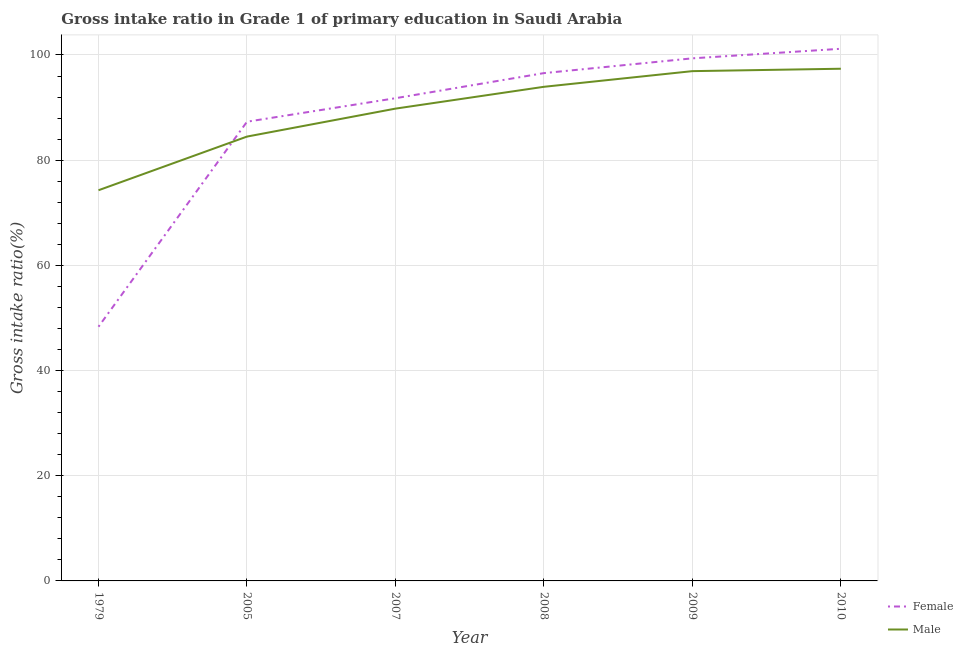Does the line corresponding to gross intake ratio(female) intersect with the line corresponding to gross intake ratio(male)?
Offer a terse response. Yes. What is the gross intake ratio(female) in 1979?
Make the answer very short. 48.33. Across all years, what is the maximum gross intake ratio(male)?
Your response must be concise. 97.39. Across all years, what is the minimum gross intake ratio(male)?
Make the answer very short. 74.28. In which year was the gross intake ratio(female) minimum?
Keep it short and to the point. 1979. What is the total gross intake ratio(male) in the graph?
Provide a short and direct response. 536.83. What is the difference between the gross intake ratio(male) in 1979 and that in 2010?
Offer a terse response. -23.1. What is the difference between the gross intake ratio(male) in 1979 and the gross intake ratio(female) in 2008?
Offer a very short reply. -22.27. What is the average gross intake ratio(male) per year?
Your response must be concise. 89.47. In the year 2010, what is the difference between the gross intake ratio(female) and gross intake ratio(male)?
Your response must be concise. 3.79. What is the ratio of the gross intake ratio(female) in 2005 to that in 2009?
Your answer should be compact. 0.88. Is the gross intake ratio(male) in 2005 less than that in 2007?
Your response must be concise. Yes. What is the difference between the highest and the second highest gross intake ratio(female)?
Offer a very short reply. 1.82. What is the difference between the highest and the lowest gross intake ratio(female)?
Ensure brevity in your answer.  52.85. In how many years, is the gross intake ratio(female) greater than the average gross intake ratio(female) taken over all years?
Offer a terse response. 4. Is the sum of the gross intake ratio(female) in 2005 and 2010 greater than the maximum gross intake ratio(male) across all years?
Your answer should be very brief. Yes. Does the gross intake ratio(female) monotonically increase over the years?
Provide a short and direct response. Yes. Is the gross intake ratio(male) strictly greater than the gross intake ratio(female) over the years?
Your answer should be compact. No. What is the difference between two consecutive major ticks on the Y-axis?
Offer a very short reply. 20. Are the values on the major ticks of Y-axis written in scientific E-notation?
Your answer should be compact. No. Does the graph contain any zero values?
Provide a succinct answer. No. Where does the legend appear in the graph?
Ensure brevity in your answer.  Bottom right. How many legend labels are there?
Your answer should be compact. 2. What is the title of the graph?
Keep it short and to the point. Gross intake ratio in Grade 1 of primary education in Saudi Arabia. What is the label or title of the Y-axis?
Your response must be concise. Gross intake ratio(%). What is the Gross intake ratio(%) of Female in 1979?
Offer a very short reply. 48.33. What is the Gross intake ratio(%) in Male in 1979?
Give a very brief answer. 74.28. What is the Gross intake ratio(%) in Female in 2005?
Provide a short and direct response. 87.31. What is the Gross intake ratio(%) of Male in 2005?
Provide a succinct answer. 84.49. What is the Gross intake ratio(%) of Female in 2007?
Keep it short and to the point. 91.78. What is the Gross intake ratio(%) of Male in 2007?
Your response must be concise. 89.8. What is the Gross intake ratio(%) in Female in 2008?
Provide a succinct answer. 96.55. What is the Gross intake ratio(%) in Male in 2008?
Offer a very short reply. 93.95. What is the Gross intake ratio(%) of Female in 2009?
Your response must be concise. 99.36. What is the Gross intake ratio(%) in Male in 2009?
Offer a very short reply. 96.93. What is the Gross intake ratio(%) in Female in 2010?
Your response must be concise. 101.18. What is the Gross intake ratio(%) in Male in 2010?
Ensure brevity in your answer.  97.39. Across all years, what is the maximum Gross intake ratio(%) of Female?
Your response must be concise. 101.18. Across all years, what is the maximum Gross intake ratio(%) of Male?
Your response must be concise. 97.39. Across all years, what is the minimum Gross intake ratio(%) in Female?
Your response must be concise. 48.33. Across all years, what is the minimum Gross intake ratio(%) of Male?
Give a very brief answer. 74.28. What is the total Gross intake ratio(%) of Female in the graph?
Ensure brevity in your answer.  524.52. What is the total Gross intake ratio(%) in Male in the graph?
Your answer should be compact. 536.83. What is the difference between the Gross intake ratio(%) in Female in 1979 and that in 2005?
Give a very brief answer. -38.98. What is the difference between the Gross intake ratio(%) in Male in 1979 and that in 2005?
Keep it short and to the point. -10.2. What is the difference between the Gross intake ratio(%) in Female in 1979 and that in 2007?
Make the answer very short. -43.45. What is the difference between the Gross intake ratio(%) of Male in 1979 and that in 2007?
Provide a short and direct response. -15.52. What is the difference between the Gross intake ratio(%) in Female in 1979 and that in 2008?
Keep it short and to the point. -48.22. What is the difference between the Gross intake ratio(%) of Male in 1979 and that in 2008?
Keep it short and to the point. -19.67. What is the difference between the Gross intake ratio(%) of Female in 1979 and that in 2009?
Your answer should be very brief. -51.03. What is the difference between the Gross intake ratio(%) in Male in 1979 and that in 2009?
Offer a very short reply. -22.65. What is the difference between the Gross intake ratio(%) of Female in 1979 and that in 2010?
Provide a short and direct response. -52.85. What is the difference between the Gross intake ratio(%) in Male in 1979 and that in 2010?
Your response must be concise. -23.1. What is the difference between the Gross intake ratio(%) of Female in 2005 and that in 2007?
Your answer should be compact. -4.47. What is the difference between the Gross intake ratio(%) of Male in 2005 and that in 2007?
Provide a succinct answer. -5.31. What is the difference between the Gross intake ratio(%) of Female in 2005 and that in 2008?
Your answer should be very brief. -9.24. What is the difference between the Gross intake ratio(%) in Male in 2005 and that in 2008?
Keep it short and to the point. -9.46. What is the difference between the Gross intake ratio(%) of Female in 2005 and that in 2009?
Your answer should be very brief. -12.05. What is the difference between the Gross intake ratio(%) in Male in 2005 and that in 2009?
Make the answer very short. -12.44. What is the difference between the Gross intake ratio(%) in Female in 2005 and that in 2010?
Offer a terse response. -13.87. What is the difference between the Gross intake ratio(%) of Male in 2005 and that in 2010?
Your response must be concise. -12.9. What is the difference between the Gross intake ratio(%) in Female in 2007 and that in 2008?
Keep it short and to the point. -4.77. What is the difference between the Gross intake ratio(%) in Male in 2007 and that in 2008?
Make the answer very short. -4.15. What is the difference between the Gross intake ratio(%) of Female in 2007 and that in 2009?
Provide a succinct answer. -7.58. What is the difference between the Gross intake ratio(%) of Male in 2007 and that in 2009?
Your answer should be very brief. -7.13. What is the difference between the Gross intake ratio(%) of Female in 2007 and that in 2010?
Make the answer very short. -9.4. What is the difference between the Gross intake ratio(%) in Male in 2007 and that in 2010?
Your response must be concise. -7.59. What is the difference between the Gross intake ratio(%) of Female in 2008 and that in 2009?
Offer a very short reply. -2.81. What is the difference between the Gross intake ratio(%) of Male in 2008 and that in 2009?
Offer a very short reply. -2.98. What is the difference between the Gross intake ratio(%) of Female in 2008 and that in 2010?
Your response must be concise. -4.63. What is the difference between the Gross intake ratio(%) of Male in 2008 and that in 2010?
Give a very brief answer. -3.44. What is the difference between the Gross intake ratio(%) in Female in 2009 and that in 2010?
Provide a short and direct response. -1.82. What is the difference between the Gross intake ratio(%) of Male in 2009 and that in 2010?
Give a very brief answer. -0.46. What is the difference between the Gross intake ratio(%) of Female in 1979 and the Gross intake ratio(%) of Male in 2005?
Give a very brief answer. -36.15. What is the difference between the Gross intake ratio(%) of Female in 1979 and the Gross intake ratio(%) of Male in 2007?
Your response must be concise. -41.47. What is the difference between the Gross intake ratio(%) of Female in 1979 and the Gross intake ratio(%) of Male in 2008?
Provide a succinct answer. -45.62. What is the difference between the Gross intake ratio(%) of Female in 1979 and the Gross intake ratio(%) of Male in 2009?
Provide a short and direct response. -48.59. What is the difference between the Gross intake ratio(%) of Female in 1979 and the Gross intake ratio(%) of Male in 2010?
Your answer should be very brief. -49.05. What is the difference between the Gross intake ratio(%) in Female in 2005 and the Gross intake ratio(%) in Male in 2007?
Your response must be concise. -2.49. What is the difference between the Gross intake ratio(%) of Female in 2005 and the Gross intake ratio(%) of Male in 2008?
Offer a very short reply. -6.64. What is the difference between the Gross intake ratio(%) of Female in 2005 and the Gross intake ratio(%) of Male in 2009?
Your answer should be compact. -9.62. What is the difference between the Gross intake ratio(%) in Female in 2005 and the Gross intake ratio(%) in Male in 2010?
Offer a terse response. -10.08. What is the difference between the Gross intake ratio(%) of Female in 2007 and the Gross intake ratio(%) of Male in 2008?
Give a very brief answer. -2.17. What is the difference between the Gross intake ratio(%) in Female in 2007 and the Gross intake ratio(%) in Male in 2009?
Your response must be concise. -5.15. What is the difference between the Gross intake ratio(%) of Female in 2007 and the Gross intake ratio(%) of Male in 2010?
Your response must be concise. -5.61. What is the difference between the Gross intake ratio(%) of Female in 2008 and the Gross intake ratio(%) of Male in 2009?
Your response must be concise. -0.38. What is the difference between the Gross intake ratio(%) in Female in 2008 and the Gross intake ratio(%) in Male in 2010?
Your answer should be compact. -0.83. What is the difference between the Gross intake ratio(%) of Female in 2009 and the Gross intake ratio(%) of Male in 2010?
Offer a very short reply. 1.98. What is the average Gross intake ratio(%) of Female per year?
Your answer should be compact. 87.42. What is the average Gross intake ratio(%) of Male per year?
Keep it short and to the point. 89.47. In the year 1979, what is the difference between the Gross intake ratio(%) of Female and Gross intake ratio(%) of Male?
Your answer should be compact. -25.95. In the year 2005, what is the difference between the Gross intake ratio(%) of Female and Gross intake ratio(%) of Male?
Your response must be concise. 2.82. In the year 2007, what is the difference between the Gross intake ratio(%) of Female and Gross intake ratio(%) of Male?
Offer a terse response. 1.98. In the year 2008, what is the difference between the Gross intake ratio(%) in Female and Gross intake ratio(%) in Male?
Offer a very short reply. 2.6. In the year 2009, what is the difference between the Gross intake ratio(%) of Female and Gross intake ratio(%) of Male?
Keep it short and to the point. 2.43. In the year 2010, what is the difference between the Gross intake ratio(%) in Female and Gross intake ratio(%) in Male?
Your answer should be compact. 3.79. What is the ratio of the Gross intake ratio(%) in Female in 1979 to that in 2005?
Ensure brevity in your answer.  0.55. What is the ratio of the Gross intake ratio(%) of Male in 1979 to that in 2005?
Provide a short and direct response. 0.88. What is the ratio of the Gross intake ratio(%) of Female in 1979 to that in 2007?
Ensure brevity in your answer.  0.53. What is the ratio of the Gross intake ratio(%) in Male in 1979 to that in 2007?
Your answer should be compact. 0.83. What is the ratio of the Gross intake ratio(%) of Female in 1979 to that in 2008?
Provide a succinct answer. 0.5. What is the ratio of the Gross intake ratio(%) in Male in 1979 to that in 2008?
Ensure brevity in your answer.  0.79. What is the ratio of the Gross intake ratio(%) of Female in 1979 to that in 2009?
Make the answer very short. 0.49. What is the ratio of the Gross intake ratio(%) in Male in 1979 to that in 2009?
Offer a terse response. 0.77. What is the ratio of the Gross intake ratio(%) of Female in 1979 to that in 2010?
Your answer should be compact. 0.48. What is the ratio of the Gross intake ratio(%) in Male in 1979 to that in 2010?
Your response must be concise. 0.76. What is the ratio of the Gross intake ratio(%) of Female in 2005 to that in 2007?
Offer a very short reply. 0.95. What is the ratio of the Gross intake ratio(%) in Male in 2005 to that in 2007?
Ensure brevity in your answer.  0.94. What is the ratio of the Gross intake ratio(%) in Female in 2005 to that in 2008?
Give a very brief answer. 0.9. What is the ratio of the Gross intake ratio(%) of Male in 2005 to that in 2008?
Make the answer very short. 0.9. What is the ratio of the Gross intake ratio(%) in Female in 2005 to that in 2009?
Keep it short and to the point. 0.88. What is the ratio of the Gross intake ratio(%) in Male in 2005 to that in 2009?
Keep it short and to the point. 0.87. What is the ratio of the Gross intake ratio(%) in Female in 2005 to that in 2010?
Provide a short and direct response. 0.86. What is the ratio of the Gross intake ratio(%) of Male in 2005 to that in 2010?
Give a very brief answer. 0.87. What is the ratio of the Gross intake ratio(%) in Female in 2007 to that in 2008?
Offer a very short reply. 0.95. What is the ratio of the Gross intake ratio(%) in Male in 2007 to that in 2008?
Provide a short and direct response. 0.96. What is the ratio of the Gross intake ratio(%) of Female in 2007 to that in 2009?
Your answer should be compact. 0.92. What is the ratio of the Gross intake ratio(%) of Male in 2007 to that in 2009?
Your response must be concise. 0.93. What is the ratio of the Gross intake ratio(%) in Female in 2007 to that in 2010?
Keep it short and to the point. 0.91. What is the ratio of the Gross intake ratio(%) of Male in 2007 to that in 2010?
Ensure brevity in your answer.  0.92. What is the ratio of the Gross intake ratio(%) of Female in 2008 to that in 2009?
Offer a very short reply. 0.97. What is the ratio of the Gross intake ratio(%) of Male in 2008 to that in 2009?
Your response must be concise. 0.97. What is the ratio of the Gross intake ratio(%) in Female in 2008 to that in 2010?
Make the answer very short. 0.95. What is the ratio of the Gross intake ratio(%) in Male in 2008 to that in 2010?
Give a very brief answer. 0.96. What is the difference between the highest and the second highest Gross intake ratio(%) in Female?
Offer a terse response. 1.82. What is the difference between the highest and the second highest Gross intake ratio(%) of Male?
Ensure brevity in your answer.  0.46. What is the difference between the highest and the lowest Gross intake ratio(%) of Female?
Provide a succinct answer. 52.85. What is the difference between the highest and the lowest Gross intake ratio(%) of Male?
Your response must be concise. 23.1. 